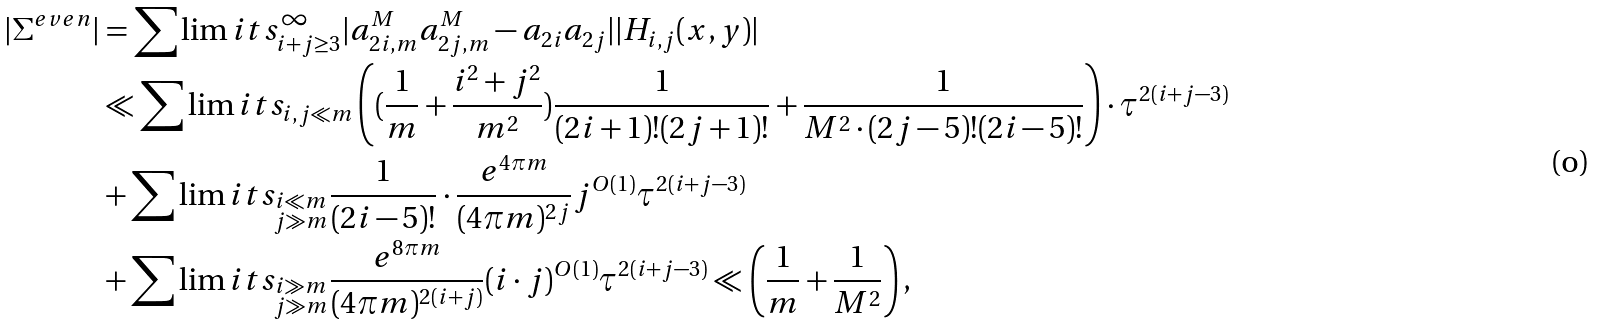Convert formula to latex. <formula><loc_0><loc_0><loc_500><loc_500>| \Sigma ^ { e v e n } | & = \sum \lim i t s _ { i + j \geq 3 } ^ { \infty } | a _ { 2 i , m } ^ { M } a _ { 2 j , m } ^ { M } - a _ { 2 i } a _ { 2 j } | | H _ { i , j } ( x , y ) | \\ & \ll \sum \lim i t s _ { i , j \ll m } \left ( ( \frac { 1 } { m } + \frac { i ^ { 2 } + j ^ { 2 } } { m ^ { 2 } } ) \frac { 1 } { ( 2 i + 1 ) ! ( 2 j + 1 ) ! } + \frac { 1 } { M ^ { 2 } \cdot ( 2 j - 5 ) ! ( 2 i - 5 ) ! } \right ) \cdot \tau ^ { 2 ( i + j - 3 ) } \\ & + \sum \lim i t s _ { \substack { i \ll m \\ j \gg m } } \frac { 1 } { ( 2 i - 5 ) ! } \cdot \frac { e ^ { 4 \pi m } } { ( 4 \pi m ) ^ { 2 j } } j ^ { O ( 1 ) } \tau ^ { 2 ( i + j - 3 ) } \\ & + \sum \lim i t s _ { \substack { i \gg m \\ j \gg m } } \frac { e ^ { 8 \pi m } } { ( 4 \pi m ) ^ { 2 ( i + j ) } } ( i \cdot j ) ^ { O ( 1 ) } \tau ^ { 2 ( i + j - 3 ) } \ll \left ( \frac { 1 } { m } + \frac { 1 } { M ^ { 2 } } \right ) ,</formula> 